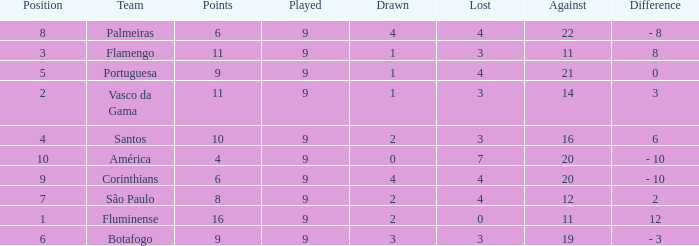Which Points is the highest one that has a Position of 1, and a Lost smaller than 0? None. 